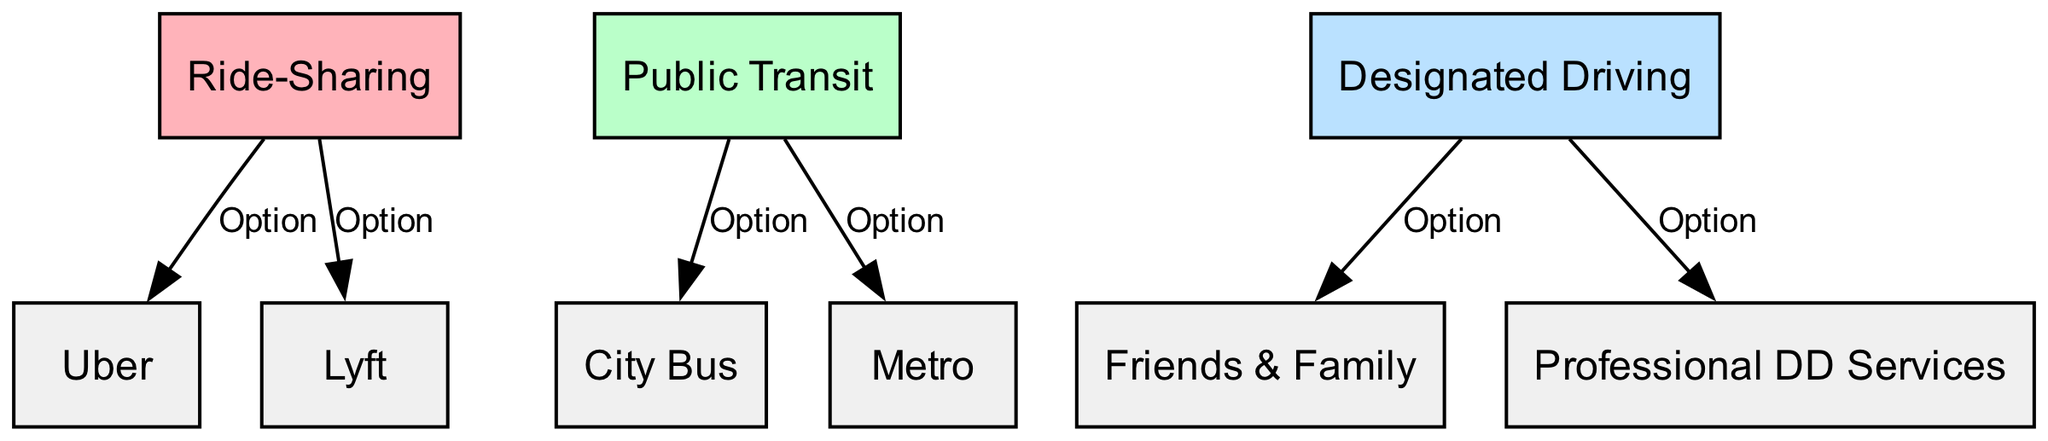What are the three main categories of transportation options presented in the diagram? The diagram displays three main categories: Ride-Sharing, Public Transit, and Designated Driving. These are the primary nodes at the top level of the diagram that group their associated options.
Answer: Ride-Sharing, Public Transit, Designated Driving How many options are listed under Ride-Sharing? Under the Ride-Sharing category, there are two options listed: Uber and Lyft. This can be determined by counting the edges that connect from Ride-Sharing to its respective options.
Answer: 2 What transportation option is associated with public transit besides City Bus? The other transportation option associated with Public Transit is Metro. This can be found by looking at the connections from the Public Transit node to its options.
Answer: Metro Which designated driving option is referred to as Professional DD Services? Professional DD Services is explicitly one of the options listed under the Designated Driving category. This can be identified by tracing the edge leading from Designated Driving to this specific node.
Answer: Professional DD Services How many edges are there in the diagram? By counting all the connections (edges) from parent categories to their respective options, there are a total of six edges connecting the nodes.
Answer: 6 What two ride-sharing services are mentioned? The two ride-sharing services mentioned are Uber and Lyft, which branch out from the Ride-Sharing node in the diagram.
Answer: Uber, Lyft Which category includes Friends & Family as an option? Friends & Family is included under the Designated Driving category, which can be confirmed by noting the connection from Designated Driving to this option.
Answer: Designated Driving How many public transit options are there in total? There are two public transit options: City Bus and Metro. This is determined by examining the edges stemming from the Public Transit node.
Answer: 2 